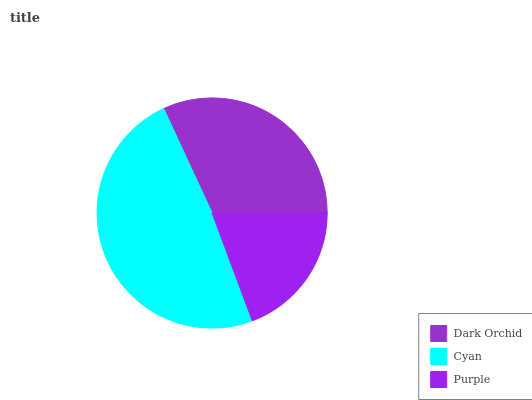Is Purple the minimum?
Answer yes or no. Yes. Is Cyan the maximum?
Answer yes or no. Yes. Is Cyan the minimum?
Answer yes or no. No. Is Purple the maximum?
Answer yes or no. No. Is Cyan greater than Purple?
Answer yes or no. Yes. Is Purple less than Cyan?
Answer yes or no. Yes. Is Purple greater than Cyan?
Answer yes or no. No. Is Cyan less than Purple?
Answer yes or no. No. Is Dark Orchid the high median?
Answer yes or no. Yes. Is Dark Orchid the low median?
Answer yes or no. Yes. Is Cyan the high median?
Answer yes or no. No. Is Purple the low median?
Answer yes or no. No. 